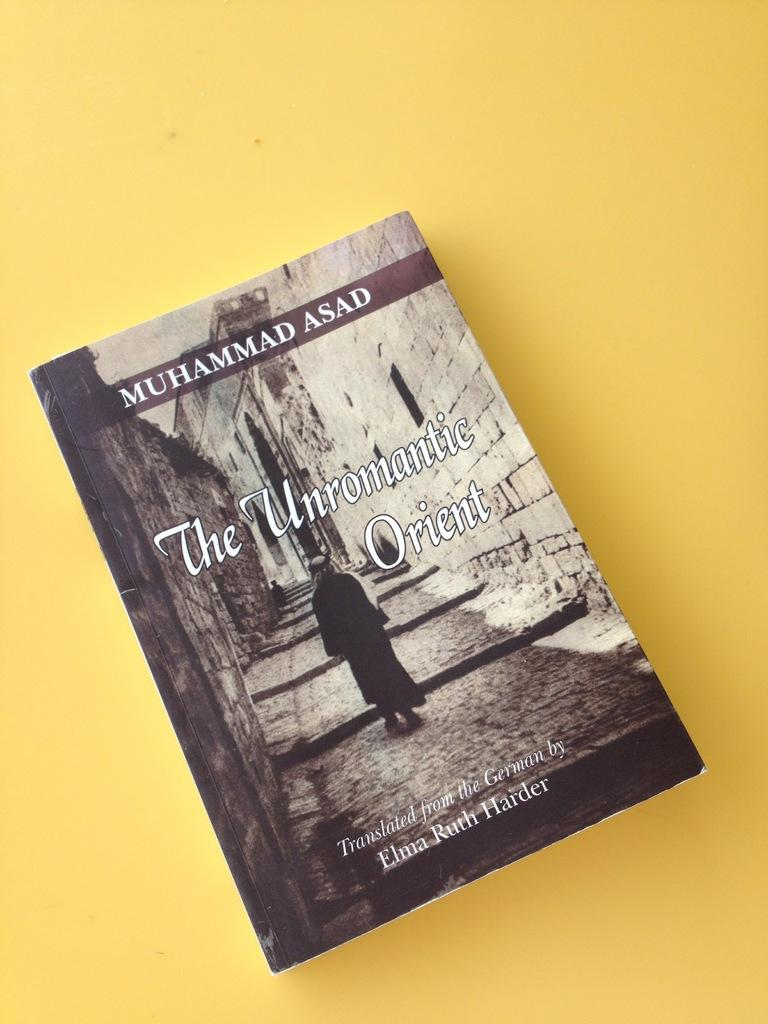What object can be seen in the image? There is a book in the image. What color is the background of the image? The background of the image is yellow. Is there a stocking hanging from the book in the image? There is no stocking present in the image. What rule is being enforced in the image? There is no rule being enforced in the image, as it only features a book and a yellow background. 